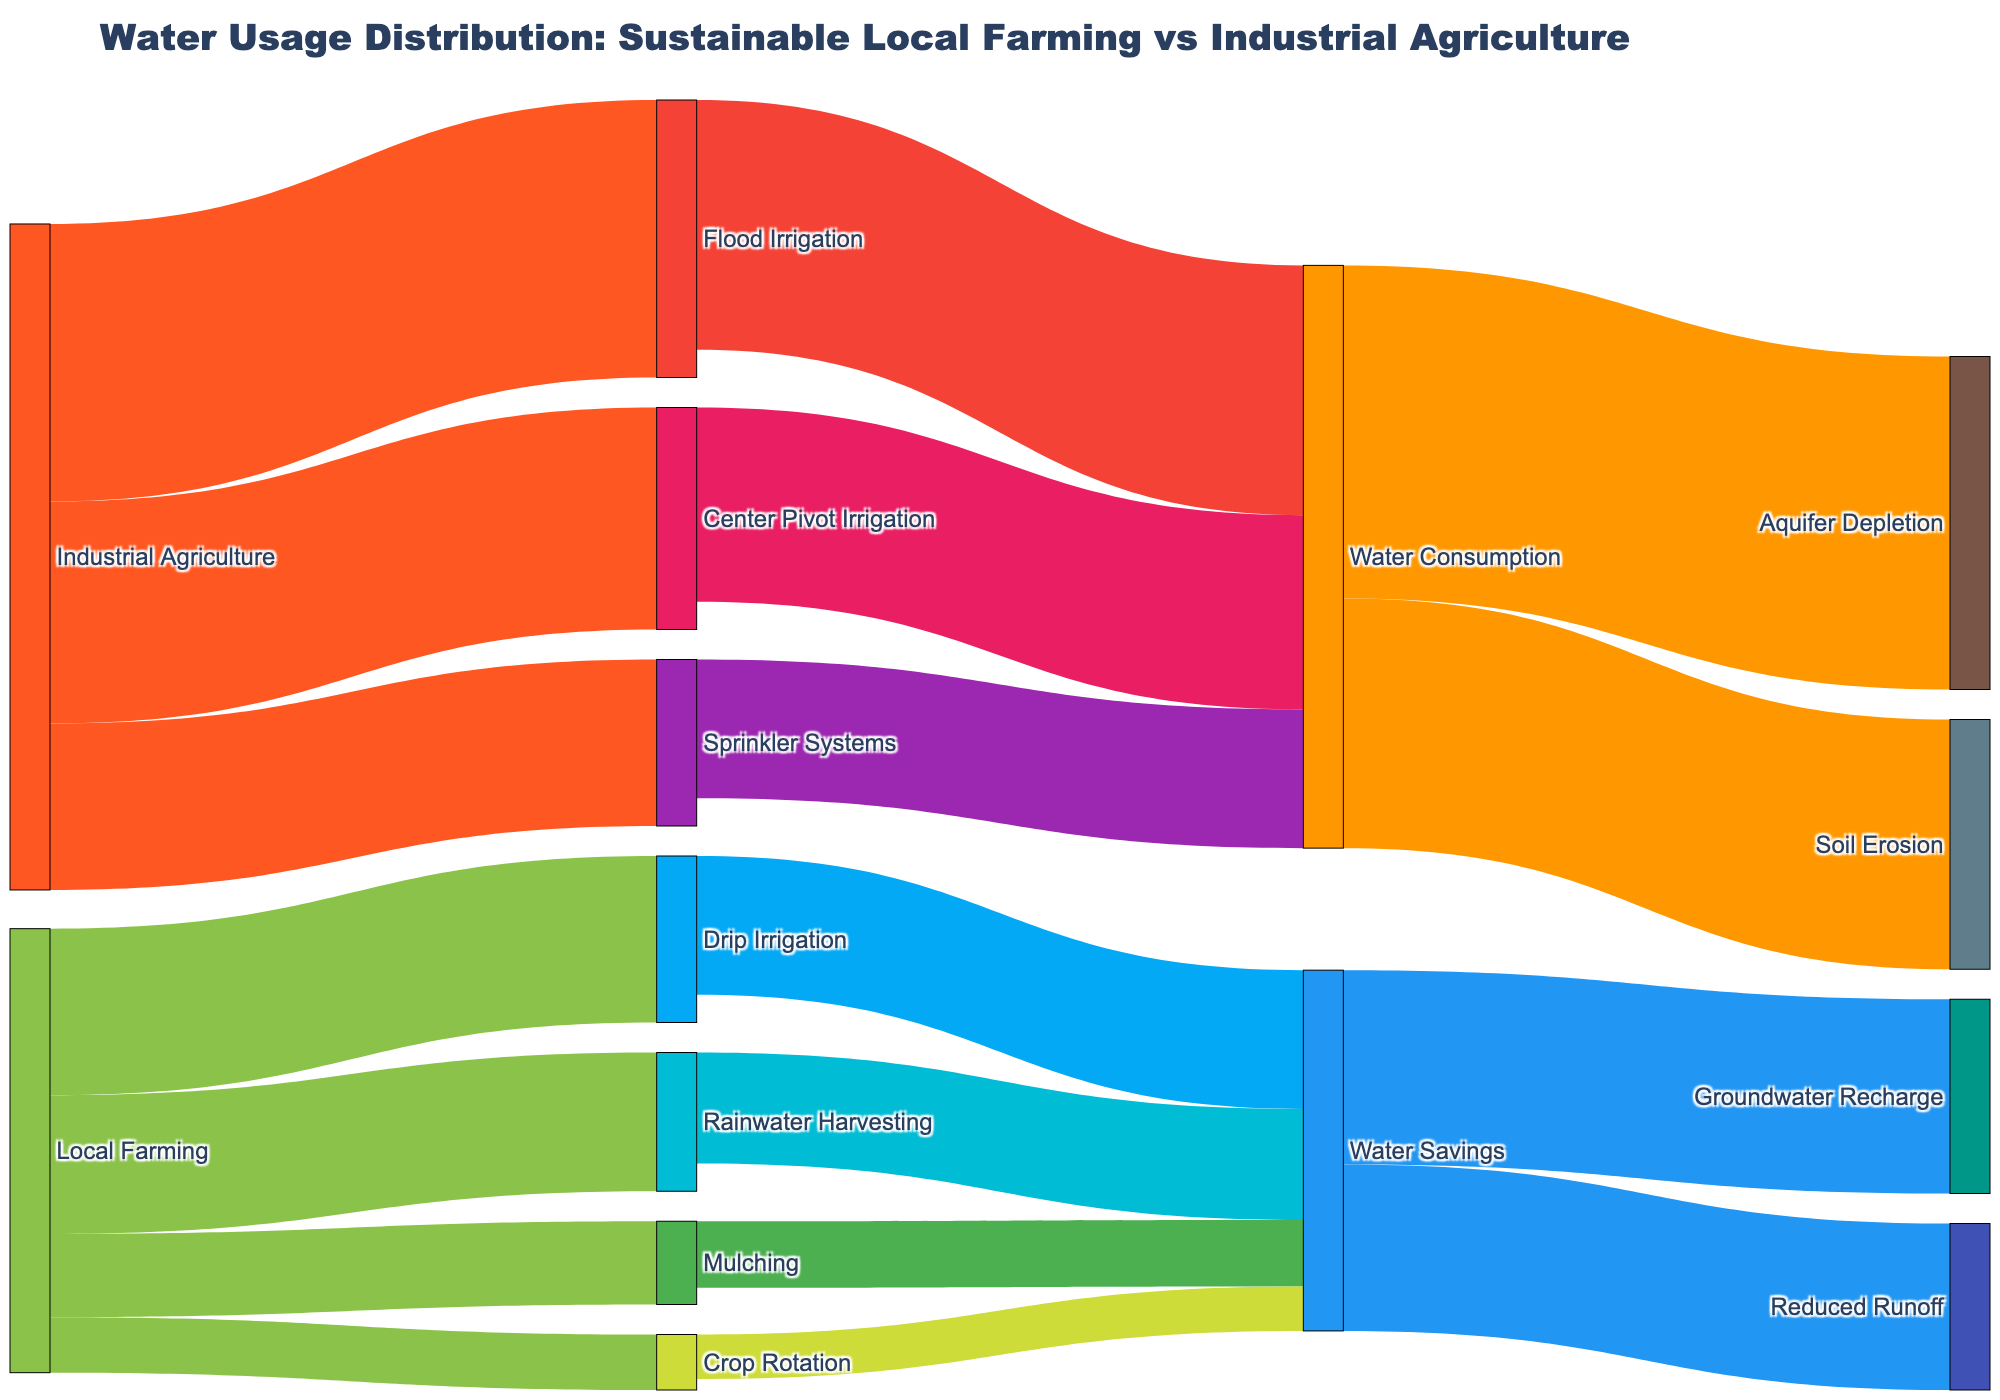What is the title of the Sankey Diagram? The title of the Sankey diagram is written at the top of the figure. You can read it directly from there.
Answer: Water Usage Distribution: Sustainable Local Farming vs Industrial Agriculture How much water is used in Drip Irrigation from Local Farming? Trace the flow from "Local Farming" to "Drip Irrigation" and read the value of the link between them.
Answer: 30 Which method in Industrial Agriculture uses the most water? Look for the highest value link originating from "Industrial Agriculture" and leading to any irrigation method.
Answer: Flood Irrigation What is the total water usage in Local Farming? Sum up the values of all the links originating from "Local Farming". 30 + 25 + 15 + 10 = 80.
Answer: 80 How much water savings is achieved through Mulching? Trace the flow from "Mulching" to "Water Savings" and read the value of the link between them.
Answer: 12 Compare the water consumption between Center Pivot Irrigation and Sprinkler Systems. Find the values of water consumption for both methods and compare them. Center Pivot Irrigation has 35, and Sprinkler Systems has 25. 35 is greater than 25.
Answer: Center Pivot Irrigation uses more water than Sprinkler Systems What are the environmental consequences of water consumption in Industrial Agriculture? Follow the flow from "Water Consumption" to its targets and list the consequences.
Answer: Aquifer Depletion and Soil Erosion How much total water savings do Groundwater Recharge and Reduced Runoff collectively represent? Sum the values of links from "Water Savings" to both "Groundwater Recharge" and "Reduced Runoff". 35 + 30 = 65.
Answer: 65 What portion of water savings in Rainwater Harvesting contributes to reduced runoff? Trace the flow from "Rainwater Harvesting" to "Water Savings" and then to "Reduced Runoff", and find the corresponding value.
Answer: 20 